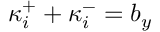Convert formula to latex. <formula><loc_0><loc_0><loc_500><loc_500>\kappa _ { i } ^ { + } + \kappa _ { i } ^ { - } = b _ { y }</formula> 